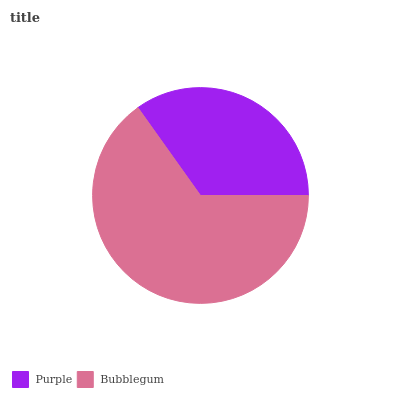Is Purple the minimum?
Answer yes or no. Yes. Is Bubblegum the maximum?
Answer yes or no. Yes. Is Bubblegum the minimum?
Answer yes or no. No. Is Bubblegum greater than Purple?
Answer yes or no. Yes. Is Purple less than Bubblegum?
Answer yes or no. Yes. Is Purple greater than Bubblegum?
Answer yes or no. No. Is Bubblegum less than Purple?
Answer yes or no. No. Is Bubblegum the high median?
Answer yes or no. Yes. Is Purple the low median?
Answer yes or no. Yes. Is Purple the high median?
Answer yes or no. No. Is Bubblegum the low median?
Answer yes or no. No. 